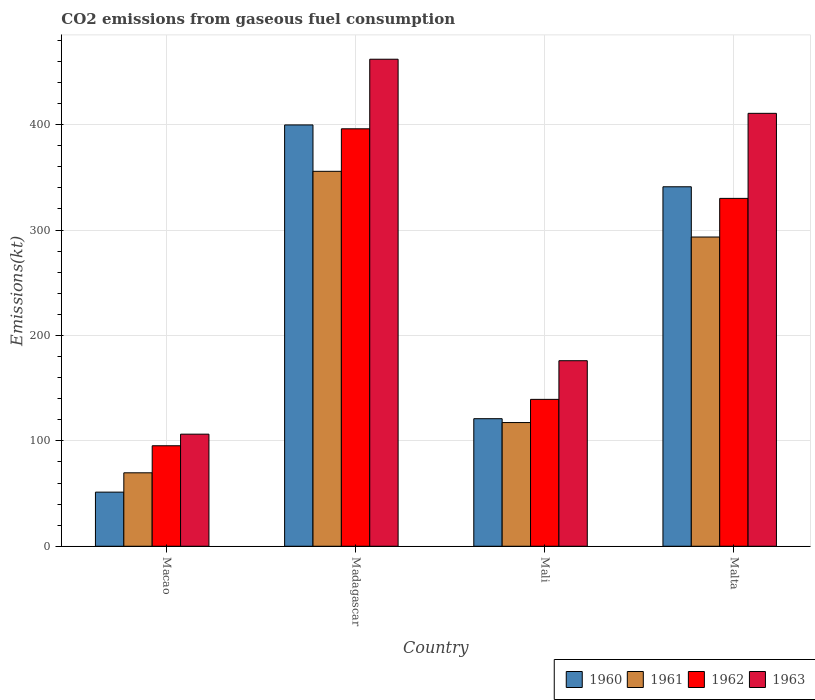Are the number of bars per tick equal to the number of legend labels?
Offer a very short reply. Yes. How many bars are there on the 2nd tick from the left?
Your answer should be very brief. 4. What is the label of the 3rd group of bars from the left?
Provide a succinct answer. Mali. What is the amount of CO2 emitted in 1962 in Macao?
Offer a terse response. 95.34. Across all countries, what is the maximum amount of CO2 emitted in 1961?
Provide a succinct answer. 355.7. Across all countries, what is the minimum amount of CO2 emitted in 1963?
Make the answer very short. 106.34. In which country was the amount of CO2 emitted in 1961 maximum?
Give a very brief answer. Madagascar. In which country was the amount of CO2 emitted in 1962 minimum?
Ensure brevity in your answer.  Macao. What is the total amount of CO2 emitted in 1961 in the graph?
Your response must be concise. 836.08. What is the difference between the amount of CO2 emitted in 1961 in Mali and that in Malta?
Give a very brief answer. -176.02. What is the difference between the amount of CO2 emitted in 1963 in Mali and the amount of CO2 emitted in 1962 in Macao?
Keep it short and to the point. 80.67. What is the average amount of CO2 emitted in 1960 per country?
Your answer should be very brief. 228.27. What is the difference between the amount of CO2 emitted of/in 1962 and amount of CO2 emitted of/in 1963 in Macao?
Offer a very short reply. -11. What is the ratio of the amount of CO2 emitted in 1960 in Madagascar to that in Malta?
Provide a short and direct response. 1.17. Is the difference between the amount of CO2 emitted in 1962 in Madagascar and Mali greater than the difference between the amount of CO2 emitted in 1963 in Madagascar and Mali?
Make the answer very short. No. What is the difference between the highest and the second highest amount of CO2 emitted in 1960?
Your answer should be very brief. -220.02. What is the difference between the highest and the lowest amount of CO2 emitted in 1962?
Offer a very short reply. 300.69. Are all the bars in the graph horizontal?
Keep it short and to the point. No. What is the difference between two consecutive major ticks on the Y-axis?
Provide a succinct answer. 100. Are the values on the major ticks of Y-axis written in scientific E-notation?
Offer a very short reply. No. Does the graph contain any zero values?
Your answer should be very brief. No. How many legend labels are there?
Give a very brief answer. 4. How are the legend labels stacked?
Your answer should be compact. Horizontal. What is the title of the graph?
Your answer should be very brief. CO2 emissions from gaseous fuel consumption. Does "1999" appear as one of the legend labels in the graph?
Offer a very short reply. No. What is the label or title of the X-axis?
Your answer should be compact. Country. What is the label or title of the Y-axis?
Your answer should be compact. Emissions(kt). What is the Emissions(kt) of 1960 in Macao?
Give a very brief answer. 51.34. What is the Emissions(kt) of 1961 in Macao?
Provide a short and direct response. 69.67. What is the Emissions(kt) of 1962 in Macao?
Your answer should be very brief. 95.34. What is the Emissions(kt) of 1963 in Macao?
Your answer should be compact. 106.34. What is the Emissions(kt) of 1960 in Madagascar?
Provide a short and direct response. 399.7. What is the Emissions(kt) in 1961 in Madagascar?
Keep it short and to the point. 355.7. What is the Emissions(kt) in 1962 in Madagascar?
Provide a short and direct response. 396.04. What is the Emissions(kt) of 1963 in Madagascar?
Provide a succinct answer. 462.04. What is the Emissions(kt) of 1960 in Mali?
Offer a very short reply. 121.01. What is the Emissions(kt) in 1961 in Mali?
Give a very brief answer. 117.34. What is the Emissions(kt) in 1962 in Mali?
Keep it short and to the point. 139.35. What is the Emissions(kt) in 1963 in Mali?
Your answer should be compact. 176.02. What is the Emissions(kt) of 1960 in Malta?
Provide a short and direct response. 341.03. What is the Emissions(kt) in 1961 in Malta?
Offer a terse response. 293.36. What is the Emissions(kt) of 1962 in Malta?
Your answer should be very brief. 330.03. What is the Emissions(kt) of 1963 in Malta?
Make the answer very short. 410.7. Across all countries, what is the maximum Emissions(kt) in 1960?
Your answer should be very brief. 399.7. Across all countries, what is the maximum Emissions(kt) of 1961?
Keep it short and to the point. 355.7. Across all countries, what is the maximum Emissions(kt) of 1962?
Make the answer very short. 396.04. Across all countries, what is the maximum Emissions(kt) in 1963?
Offer a very short reply. 462.04. Across all countries, what is the minimum Emissions(kt) of 1960?
Keep it short and to the point. 51.34. Across all countries, what is the minimum Emissions(kt) of 1961?
Offer a very short reply. 69.67. Across all countries, what is the minimum Emissions(kt) in 1962?
Offer a very short reply. 95.34. Across all countries, what is the minimum Emissions(kt) in 1963?
Give a very brief answer. 106.34. What is the total Emissions(kt) of 1960 in the graph?
Your response must be concise. 913.08. What is the total Emissions(kt) in 1961 in the graph?
Your answer should be compact. 836.08. What is the total Emissions(kt) of 1962 in the graph?
Your response must be concise. 960.75. What is the total Emissions(kt) of 1963 in the graph?
Provide a succinct answer. 1155.11. What is the difference between the Emissions(kt) in 1960 in Macao and that in Madagascar?
Make the answer very short. -348.37. What is the difference between the Emissions(kt) of 1961 in Macao and that in Madagascar?
Offer a very short reply. -286.03. What is the difference between the Emissions(kt) in 1962 in Macao and that in Madagascar?
Your response must be concise. -300.69. What is the difference between the Emissions(kt) of 1963 in Macao and that in Madagascar?
Your answer should be compact. -355.7. What is the difference between the Emissions(kt) in 1960 in Macao and that in Mali?
Your answer should be very brief. -69.67. What is the difference between the Emissions(kt) of 1961 in Macao and that in Mali?
Give a very brief answer. -47.67. What is the difference between the Emissions(kt) of 1962 in Macao and that in Mali?
Keep it short and to the point. -44. What is the difference between the Emissions(kt) in 1963 in Macao and that in Mali?
Your answer should be very brief. -69.67. What is the difference between the Emissions(kt) in 1960 in Macao and that in Malta?
Your response must be concise. -289.69. What is the difference between the Emissions(kt) of 1961 in Macao and that in Malta?
Keep it short and to the point. -223.69. What is the difference between the Emissions(kt) of 1962 in Macao and that in Malta?
Keep it short and to the point. -234.69. What is the difference between the Emissions(kt) in 1963 in Macao and that in Malta?
Keep it short and to the point. -304.36. What is the difference between the Emissions(kt) of 1960 in Madagascar and that in Mali?
Ensure brevity in your answer.  278.69. What is the difference between the Emissions(kt) of 1961 in Madagascar and that in Mali?
Provide a succinct answer. 238.35. What is the difference between the Emissions(kt) in 1962 in Madagascar and that in Mali?
Offer a terse response. 256.69. What is the difference between the Emissions(kt) in 1963 in Madagascar and that in Mali?
Keep it short and to the point. 286.03. What is the difference between the Emissions(kt) in 1960 in Madagascar and that in Malta?
Offer a very short reply. 58.67. What is the difference between the Emissions(kt) in 1961 in Madagascar and that in Malta?
Make the answer very short. 62.34. What is the difference between the Emissions(kt) in 1962 in Madagascar and that in Malta?
Your answer should be compact. 66.01. What is the difference between the Emissions(kt) in 1963 in Madagascar and that in Malta?
Your answer should be compact. 51.34. What is the difference between the Emissions(kt) of 1960 in Mali and that in Malta?
Offer a very short reply. -220.02. What is the difference between the Emissions(kt) of 1961 in Mali and that in Malta?
Your answer should be very brief. -176.02. What is the difference between the Emissions(kt) of 1962 in Mali and that in Malta?
Make the answer very short. -190.68. What is the difference between the Emissions(kt) of 1963 in Mali and that in Malta?
Offer a terse response. -234.69. What is the difference between the Emissions(kt) in 1960 in Macao and the Emissions(kt) in 1961 in Madagascar?
Give a very brief answer. -304.36. What is the difference between the Emissions(kt) in 1960 in Macao and the Emissions(kt) in 1962 in Madagascar?
Give a very brief answer. -344.7. What is the difference between the Emissions(kt) in 1960 in Macao and the Emissions(kt) in 1963 in Madagascar?
Provide a succinct answer. -410.7. What is the difference between the Emissions(kt) in 1961 in Macao and the Emissions(kt) in 1962 in Madagascar?
Your answer should be very brief. -326.36. What is the difference between the Emissions(kt) of 1961 in Macao and the Emissions(kt) of 1963 in Madagascar?
Provide a short and direct response. -392.37. What is the difference between the Emissions(kt) in 1962 in Macao and the Emissions(kt) in 1963 in Madagascar?
Provide a short and direct response. -366.7. What is the difference between the Emissions(kt) in 1960 in Macao and the Emissions(kt) in 1961 in Mali?
Make the answer very short. -66.01. What is the difference between the Emissions(kt) of 1960 in Macao and the Emissions(kt) of 1962 in Mali?
Offer a very short reply. -88.01. What is the difference between the Emissions(kt) in 1960 in Macao and the Emissions(kt) in 1963 in Mali?
Offer a terse response. -124.68. What is the difference between the Emissions(kt) in 1961 in Macao and the Emissions(kt) in 1962 in Mali?
Your answer should be compact. -69.67. What is the difference between the Emissions(kt) of 1961 in Macao and the Emissions(kt) of 1963 in Mali?
Offer a very short reply. -106.34. What is the difference between the Emissions(kt) in 1962 in Macao and the Emissions(kt) in 1963 in Mali?
Give a very brief answer. -80.67. What is the difference between the Emissions(kt) of 1960 in Macao and the Emissions(kt) of 1961 in Malta?
Ensure brevity in your answer.  -242.02. What is the difference between the Emissions(kt) of 1960 in Macao and the Emissions(kt) of 1962 in Malta?
Offer a terse response. -278.69. What is the difference between the Emissions(kt) in 1960 in Macao and the Emissions(kt) in 1963 in Malta?
Provide a short and direct response. -359.37. What is the difference between the Emissions(kt) of 1961 in Macao and the Emissions(kt) of 1962 in Malta?
Provide a short and direct response. -260.36. What is the difference between the Emissions(kt) of 1961 in Macao and the Emissions(kt) of 1963 in Malta?
Offer a very short reply. -341.03. What is the difference between the Emissions(kt) in 1962 in Macao and the Emissions(kt) in 1963 in Malta?
Your response must be concise. -315.36. What is the difference between the Emissions(kt) in 1960 in Madagascar and the Emissions(kt) in 1961 in Mali?
Provide a short and direct response. 282.36. What is the difference between the Emissions(kt) of 1960 in Madagascar and the Emissions(kt) of 1962 in Mali?
Your answer should be very brief. 260.36. What is the difference between the Emissions(kt) of 1960 in Madagascar and the Emissions(kt) of 1963 in Mali?
Your response must be concise. 223.69. What is the difference between the Emissions(kt) of 1961 in Madagascar and the Emissions(kt) of 1962 in Mali?
Ensure brevity in your answer.  216.35. What is the difference between the Emissions(kt) of 1961 in Madagascar and the Emissions(kt) of 1963 in Mali?
Keep it short and to the point. 179.68. What is the difference between the Emissions(kt) of 1962 in Madagascar and the Emissions(kt) of 1963 in Mali?
Offer a very short reply. 220.02. What is the difference between the Emissions(kt) in 1960 in Madagascar and the Emissions(kt) in 1961 in Malta?
Your response must be concise. 106.34. What is the difference between the Emissions(kt) in 1960 in Madagascar and the Emissions(kt) in 1962 in Malta?
Ensure brevity in your answer.  69.67. What is the difference between the Emissions(kt) in 1960 in Madagascar and the Emissions(kt) in 1963 in Malta?
Your answer should be compact. -11. What is the difference between the Emissions(kt) in 1961 in Madagascar and the Emissions(kt) in 1962 in Malta?
Offer a very short reply. 25.67. What is the difference between the Emissions(kt) in 1961 in Madagascar and the Emissions(kt) in 1963 in Malta?
Give a very brief answer. -55.01. What is the difference between the Emissions(kt) of 1962 in Madagascar and the Emissions(kt) of 1963 in Malta?
Your answer should be compact. -14.67. What is the difference between the Emissions(kt) in 1960 in Mali and the Emissions(kt) in 1961 in Malta?
Your answer should be very brief. -172.35. What is the difference between the Emissions(kt) in 1960 in Mali and the Emissions(kt) in 1962 in Malta?
Keep it short and to the point. -209.02. What is the difference between the Emissions(kt) in 1960 in Mali and the Emissions(kt) in 1963 in Malta?
Make the answer very short. -289.69. What is the difference between the Emissions(kt) in 1961 in Mali and the Emissions(kt) in 1962 in Malta?
Provide a short and direct response. -212.69. What is the difference between the Emissions(kt) in 1961 in Mali and the Emissions(kt) in 1963 in Malta?
Make the answer very short. -293.36. What is the difference between the Emissions(kt) in 1962 in Mali and the Emissions(kt) in 1963 in Malta?
Provide a short and direct response. -271.36. What is the average Emissions(kt) in 1960 per country?
Your answer should be very brief. 228.27. What is the average Emissions(kt) in 1961 per country?
Your response must be concise. 209.02. What is the average Emissions(kt) of 1962 per country?
Provide a succinct answer. 240.19. What is the average Emissions(kt) in 1963 per country?
Your response must be concise. 288.78. What is the difference between the Emissions(kt) in 1960 and Emissions(kt) in 1961 in Macao?
Your answer should be very brief. -18.34. What is the difference between the Emissions(kt) in 1960 and Emissions(kt) in 1962 in Macao?
Your response must be concise. -44. What is the difference between the Emissions(kt) in 1960 and Emissions(kt) in 1963 in Macao?
Ensure brevity in your answer.  -55.01. What is the difference between the Emissions(kt) in 1961 and Emissions(kt) in 1962 in Macao?
Provide a short and direct response. -25.67. What is the difference between the Emissions(kt) of 1961 and Emissions(kt) of 1963 in Macao?
Give a very brief answer. -36.67. What is the difference between the Emissions(kt) in 1962 and Emissions(kt) in 1963 in Macao?
Offer a very short reply. -11. What is the difference between the Emissions(kt) in 1960 and Emissions(kt) in 1961 in Madagascar?
Keep it short and to the point. 44. What is the difference between the Emissions(kt) in 1960 and Emissions(kt) in 1962 in Madagascar?
Your answer should be very brief. 3.67. What is the difference between the Emissions(kt) in 1960 and Emissions(kt) in 1963 in Madagascar?
Your response must be concise. -62.34. What is the difference between the Emissions(kt) of 1961 and Emissions(kt) of 1962 in Madagascar?
Offer a very short reply. -40.34. What is the difference between the Emissions(kt) in 1961 and Emissions(kt) in 1963 in Madagascar?
Your answer should be compact. -106.34. What is the difference between the Emissions(kt) in 1962 and Emissions(kt) in 1963 in Madagascar?
Your answer should be very brief. -66.01. What is the difference between the Emissions(kt) of 1960 and Emissions(kt) of 1961 in Mali?
Provide a short and direct response. 3.67. What is the difference between the Emissions(kt) of 1960 and Emissions(kt) of 1962 in Mali?
Provide a succinct answer. -18.34. What is the difference between the Emissions(kt) of 1960 and Emissions(kt) of 1963 in Mali?
Provide a short and direct response. -55.01. What is the difference between the Emissions(kt) in 1961 and Emissions(kt) in 1962 in Mali?
Give a very brief answer. -22. What is the difference between the Emissions(kt) in 1961 and Emissions(kt) in 1963 in Mali?
Provide a short and direct response. -58.67. What is the difference between the Emissions(kt) of 1962 and Emissions(kt) of 1963 in Mali?
Your answer should be compact. -36.67. What is the difference between the Emissions(kt) in 1960 and Emissions(kt) in 1961 in Malta?
Your response must be concise. 47.67. What is the difference between the Emissions(kt) in 1960 and Emissions(kt) in 1962 in Malta?
Provide a succinct answer. 11. What is the difference between the Emissions(kt) of 1960 and Emissions(kt) of 1963 in Malta?
Offer a terse response. -69.67. What is the difference between the Emissions(kt) in 1961 and Emissions(kt) in 1962 in Malta?
Provide a short and direct response. -36.67. What is the difference between the Emissions(kt) in 1961 and Emissions(kt) in 1963 in Malta?
Provide a short and direct response. -117.34. What is the difference between the Emissions(kt) of 1962 and Emissions(kt) of 1963 in Malta?
Ensure brevity in your answer.  -80.67. What is the ratio of the Emissions(kt) in 1960 in Macao to that in Madagascar?
Offer a terse response. 0.13. What is the ratio of the Emissions(kt) in 1961 in Macao to that in Madagascar?
Provide a short and direct response. 0.2. What is the ratio of the Emissions(kt) in 1962 in Macao to that in Madagascar?
Provide a short and direct response. 0.24. What is the ratio of the Emissions(kt) of 1963 in Macao to that in Madagascar?
Provide a succinct answer. 0.23. What is the ratio of the Emissions(kt) of 1960 in Macao to that in Mali?
Provide a short and direct response. 0.42. What is the ratio of the Emissions(kt) in 1961 in Macao to that in Mali?
Your answer should be compact. 0.59. What is the ratio of the Emissions(kt) in 1962 in Macao to that in Mali?
Give a very brief answer. 0.68. What is the ratio of the Emissions(kt) of 1963 in Macao to that in Mali?
Your answer should be compact. 0.6. What is the ratio of the Emissions(kt) of 1960 in Macao to that in Malta?
Give a very brief answer. 0.15. What is the ratio of the Emissions(kt) of 1961 in Macao to that in Malta?
Make the answer very short. 0.24. What is the ratio of the Emissions(kt) in 1962 in Macao to that in Malta?
Your answer should be very brief. 0.29. What is the ratio of the Emissions(kt) in 1963 in Macao to that in Malta?
Offer a terse response. 0.26. What is the ratio of the Emissions(kt) in 1960 in Madagascar to that in Mali?
Ensure brevity in your answer.  3.3. What is the ratio of the Emissions(kt) of 1961 in Madagascar to that in Mali?
Give a very brief answer. 3.03. What is the ratio of the Emissions(kt) of 1962 in Madagascar to that in Mali?
Your answer should be compact. 2.84. What is the ratio of the Emissions(kt) in 1963 in Madagascar to that in Mali?
Provide a short and direct response. 2.62. What is the ratio of the Emissions(kt) of 1960 in Madagascar to that in Malta?
Your response must be concise. 1.17. What is the ratio of the Emissions(kt) of 1961 in Madagascar to that in Malta?
Give a very brief answer. 1.21. What is the ratio of the Emissions(kt) in 1963 in Madagascar to that in Malta?
Ensure brevity in your answer.  1.12. What is the ratio of the Emissions(kt) in 1960 in Mali to that in Malta?
Provide a short and direct response. 0.35. What is the ratio of the Emissions(kt) in 1961 in Mali to that in Malta?
Your answer should be very brief. 0.4. What is the ratio of the Emissions(kt) of 1962 in Mali to that in Malta?
Provide a succinct answer. 0.42. What is the ratio of the Emissions(kt) in 1963 in Mali to that in Malta?
Your answer should be compact. 0.43. What is the difference between the highest and the second highest Emissions(kt) of 1960?
Provide a succinct answer. 58.67. What is the difference between the highest and the second highest Emissions(kt) of 1961?
Your answer should be very brief. 62.34. What is the difference between the highest and the second highest Emissions(kt) of 1962?
Provide a succinct answer. 66.01. What is the difference between the highest and the second highest Emissions(kt) in 1963?
Keep it short and to the point. 51.34. What is the difference between the highest and the lowest Emissions(kt) of 1960?
Provide a short and direct response. 348.37. What is the difference between the highest and the lowest Emissions(kt) in 1961?
Keep it short and to the point. 286.03. What is the difference between the highest and the lowest Emissions(kt) in 1962?
Your response must be concise. 300.69. What is the difference between the highest and the lowest Emissions(kt) of 1963?
Your answer should be very brief. 355.7. 